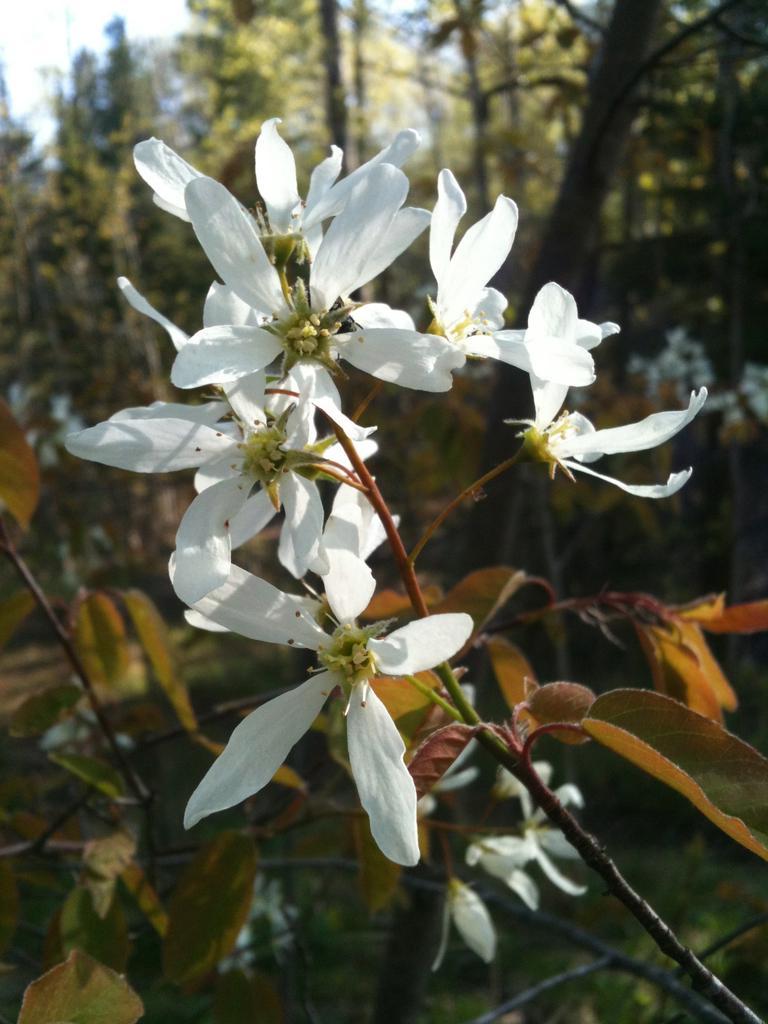Can you describe this image briefly? In this image I can see white color flowers to a stem. In the background there are many trees. At the top of the image I can see the sky. 